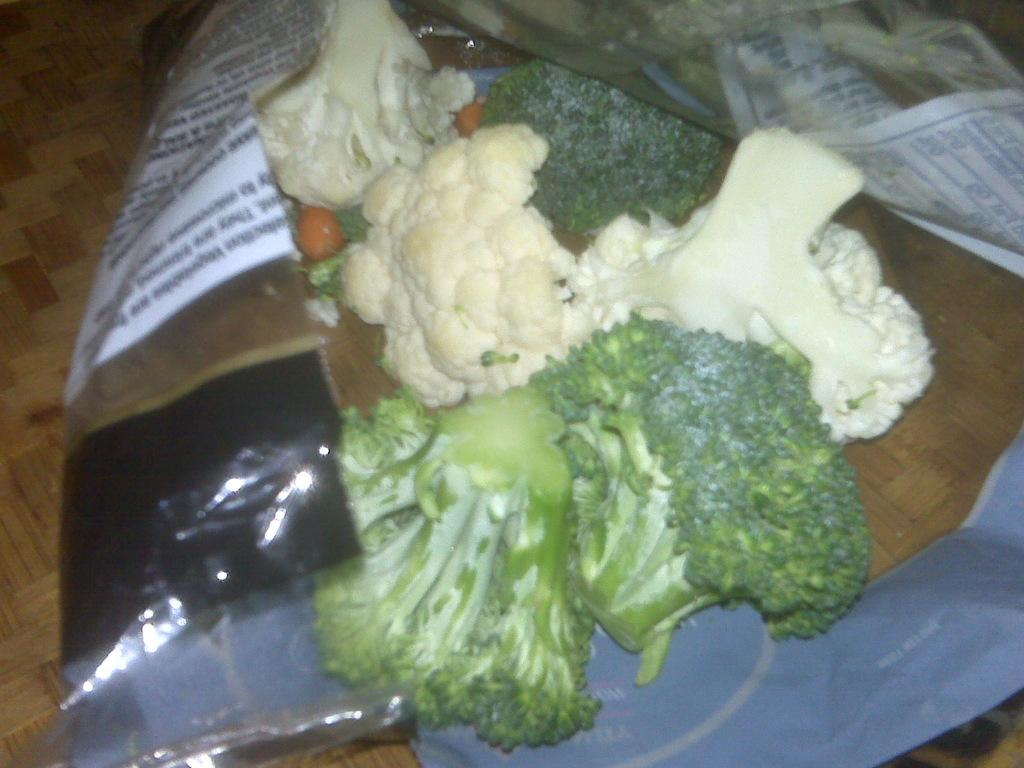What type of vegetable can be seen in the image? There is chopped cauliflower and chopped broccoli in the image. How are the cauliflower and broccoli presented in the image? The cauliflower and broccoli are covered. What is the covered cauliflower and broccoli placed on in the image? The covered cauliflower and broccoli are placed on an object. What type of worm can be seen crawling on the cauliflower in the image? There are no worms present in the image; it only features chopped cauliflower and broccoli that are covered. 